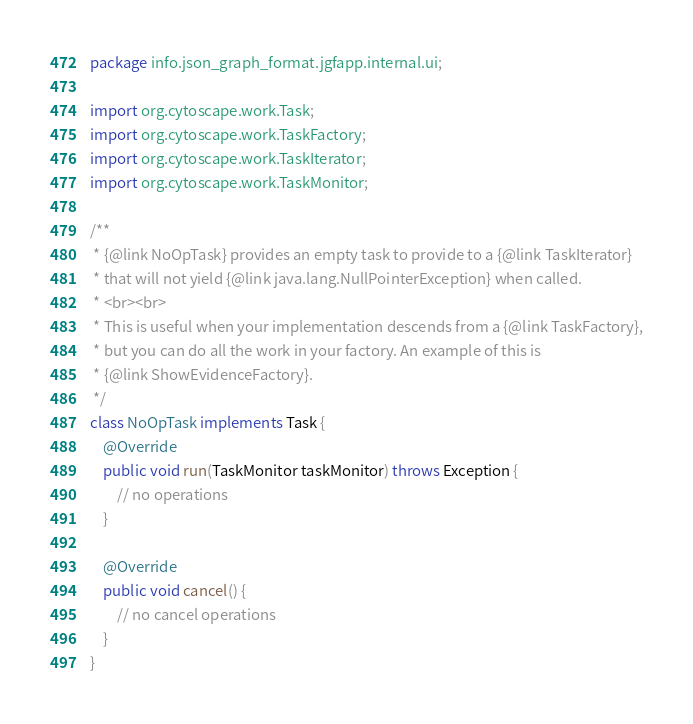<code> <loc_0><loc_0><loc_500><loc_500><_Java_>package info.json_graph_format.jgfapp.internal.ui;

import org.cytoscape.work.Task;
import org.cytoscape.work.TaskFactory;
import org.cytoscape.work.TaskIterator;
import org.cytoscape.work.TaskMonitor;

/**
 * {@link NoOpTask} provides an empty task to provide to a {@link TaskIterator}
 * that will not yield {@link java.lang.NullPointerException} when called.
 * <br><br>
 * This is useful when your implementation descends from a {@link TaskFactory},
 * but you can do all the work in your factory. An example of this is
 * {@link ShowEvidenceFactory}.
 */
class NoOpTask implements Task {
    @Override
    public void run(TaskMonitor taskMonitor) throws Exception {
        // no operations
    }

    @Override
    public void cancel() {
        // no cancel operations
    }
}
</code> 